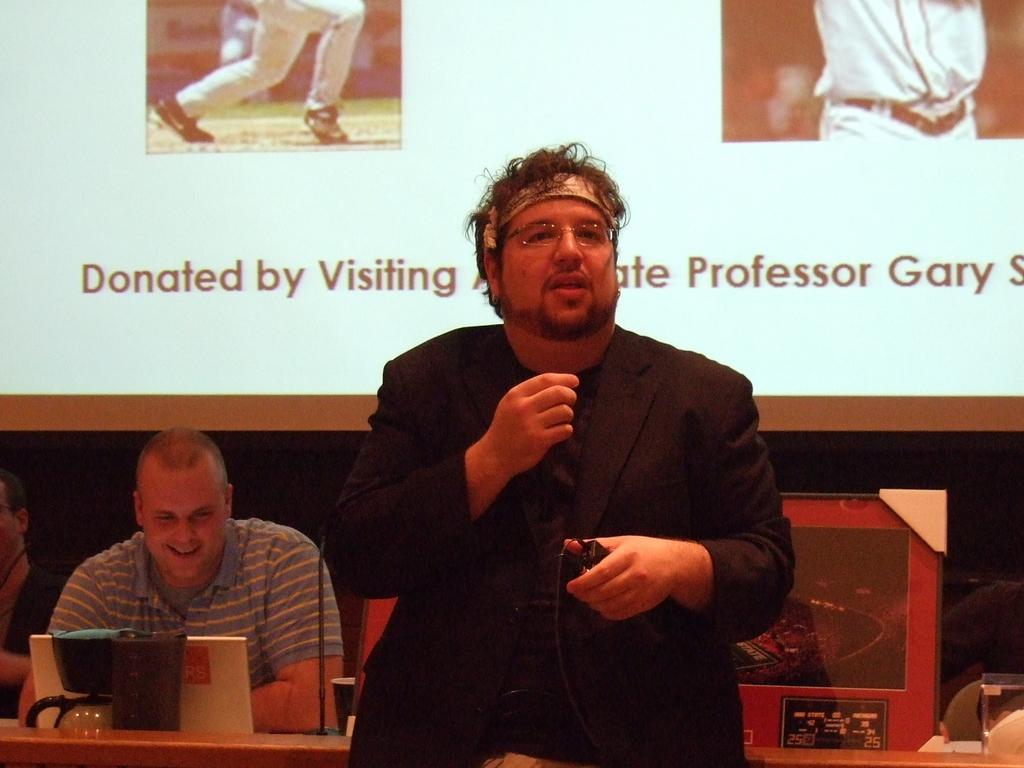Please provide a concise description of this image. This picture shows a man standing and speaking by holding microphone in his hand and we see a man seated with a smile on his face and we see a screen back of them. 